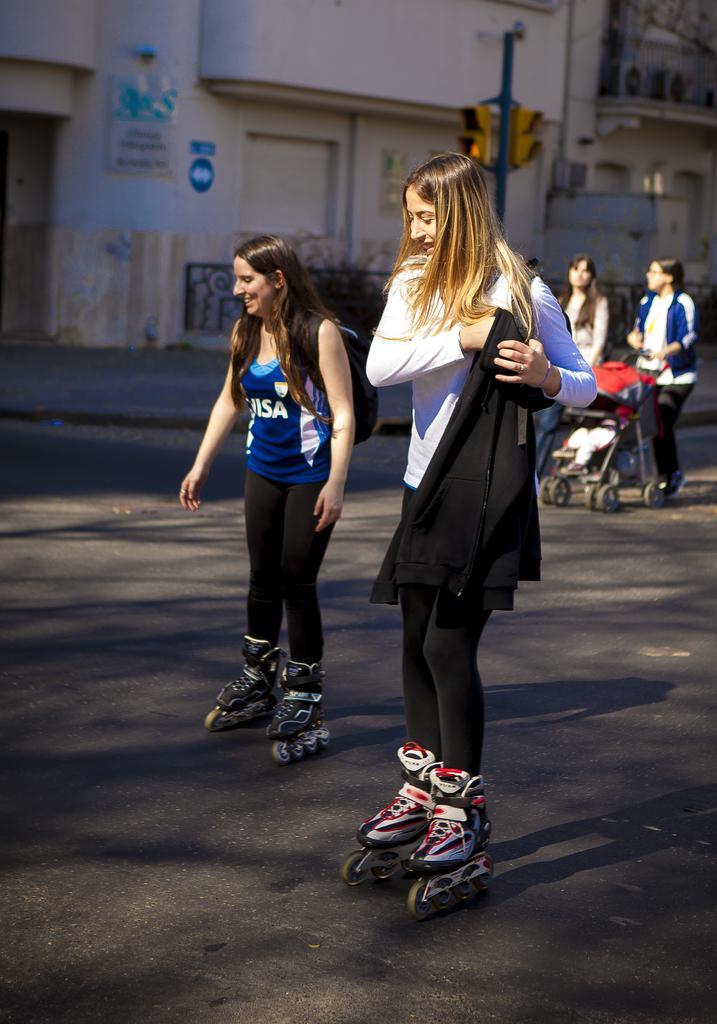Can you describe this image briefly? In this image in the center there are women skating on the road and smiling. In the background there are persons and there is a woman walking along with a trolley and there is a pole and there are buildings and in front of the buildings there are fences and on the wall of the building, there is a board with some text written on it. 